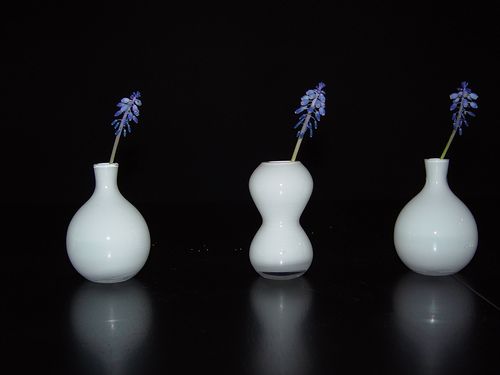<image>Why is the vase in the middle shaped differently? It's unknown why the vase in the middle is shaped differently. The shape could be due to design, esthetics, or for variety. Why is the vase in the middle shaped differently? I don't know why the vase in the middle is shaped differently. It could be for design purposes, or for variety, or maybe it's just art. 